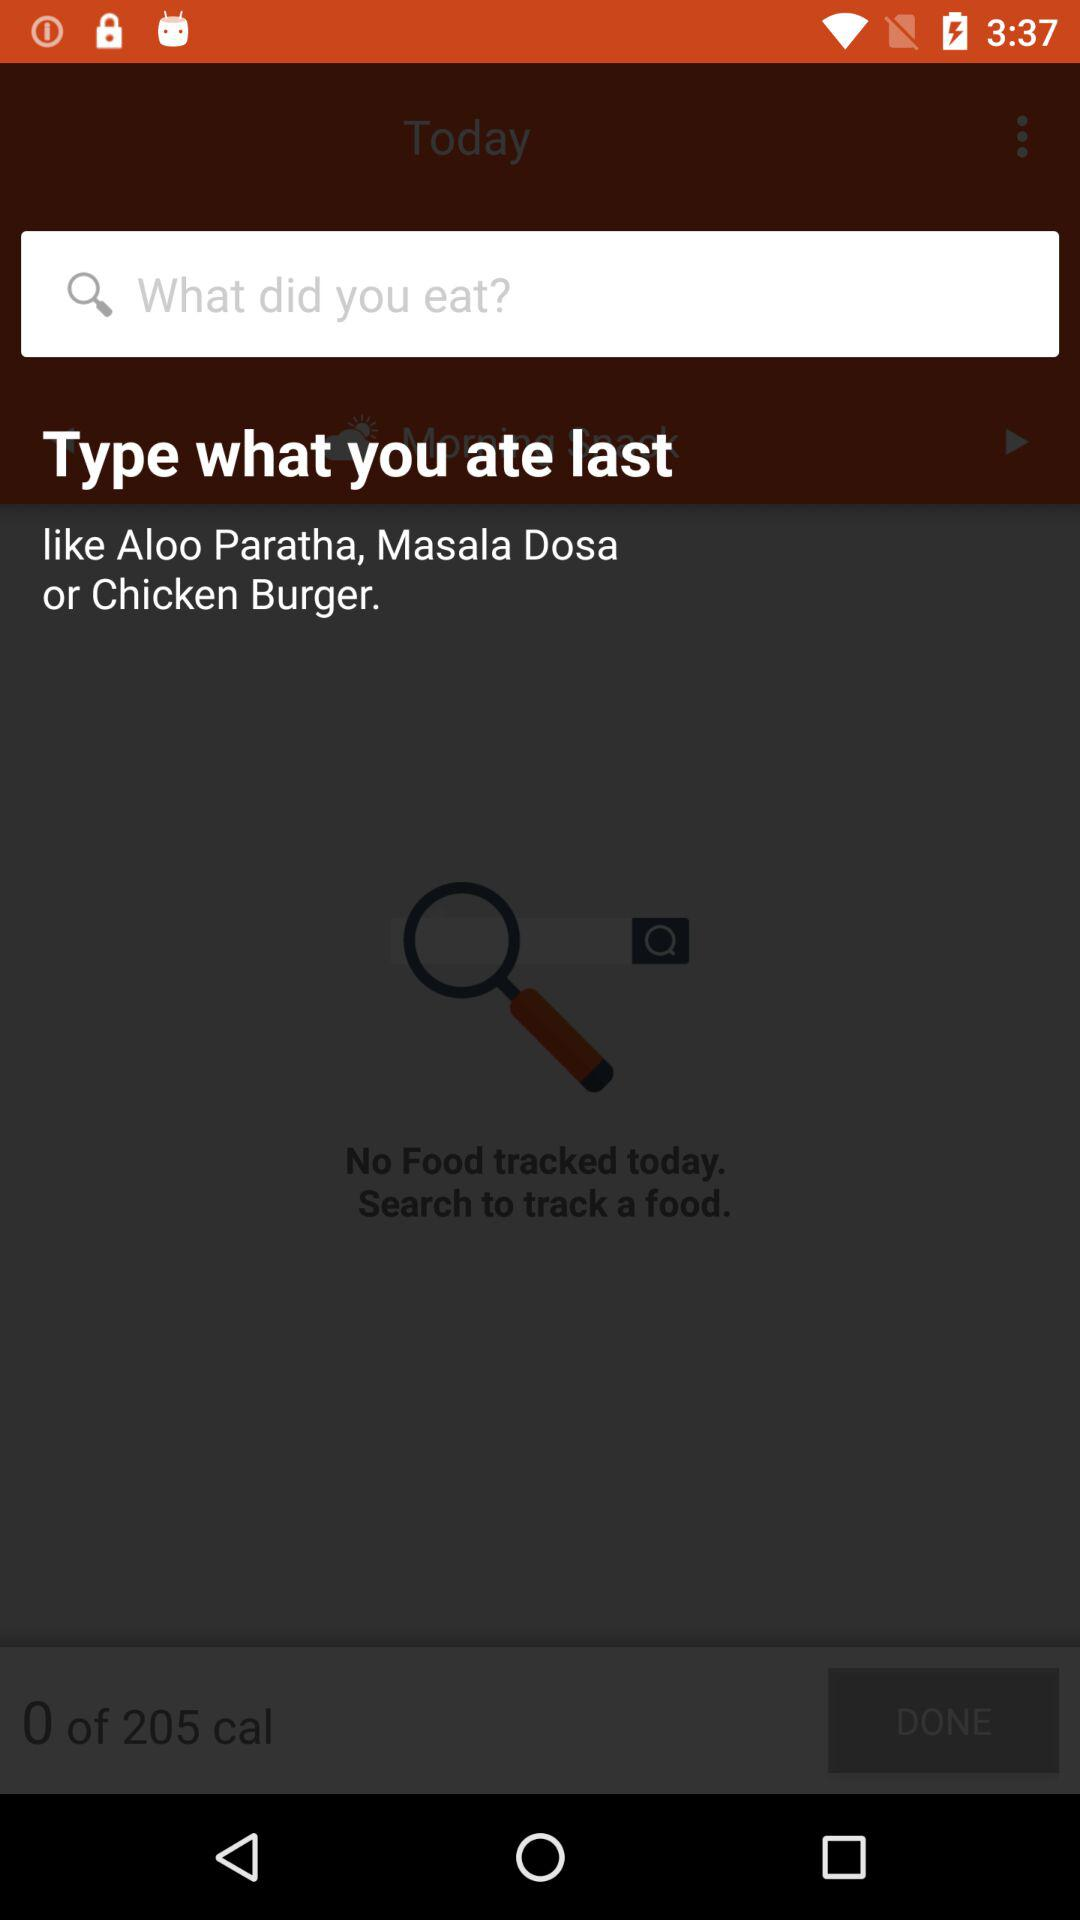How many calories are left to track?
Answer the question using a single word or phrase. 205 